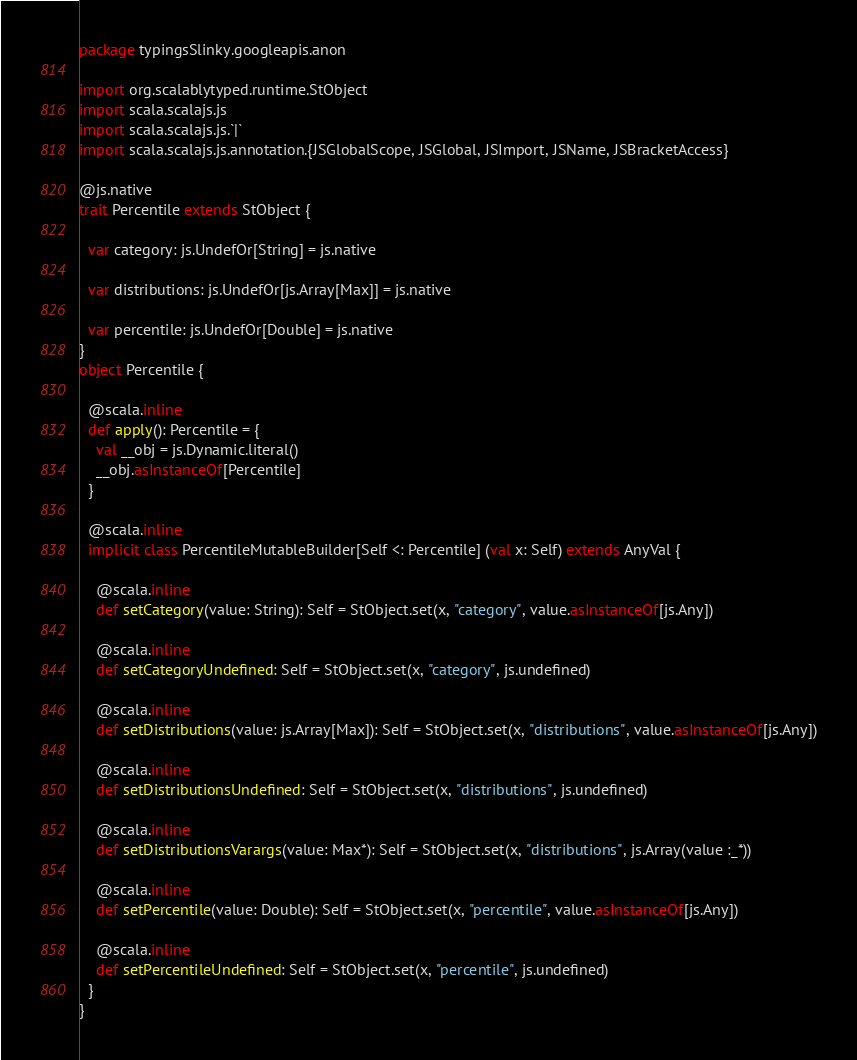Convert code to text. <code><loc_0><loc_0><loc_500><loc_500><_Scala_>package typingsSlinky.googleapis.anon

import org.scalablytyped.runtime.StObject
import scala.scalajs.js
import scala.scalajs.js.`|`
import scala.scalajs.js.annotation.{JSGlobalScope, JSGlobal, JSImport, JSName, JSBracketAccess}

@js.native
trait Percentile extends StObject {
  
  var category: js.UndefOr[String] = js.native
  
  var distributions: js.UndefOr[js.Array[Max]] = js.native
  
  var percentile: js.UndefOr[Double] = js.native
}
object Percentile {
  
  @scala.inline
  def apply(): Percentile = {
    val __obj = js.Dynamic.literal()
    __obj.asInstanceOf[Percentile]
  }
  
  @scala.inline
  implicit class PercentileMutableBuilder[Self <: Percentile] (val x: Self) extends AnyVal {
    
    @scala.inline
    def setCategory(value: String): Self = StObject.set(x, "category", value.asInstanceOf[js.Any])
    
    @scala.inline
    def setCategoryUndefined: Self = StObject.set(x, "category", js.undefined)
    
    @scala.inline
    def setDistributions(value: js.Array[Max]): Self = StObject.set(x, "distributions", value.asInstanceOf[js.Any])
    
    @scala.inline
    def setDistributionsUndefined: Self = StObject.set(x, "distributions", js.undefined)
    
    @scala.inline
    def setDistributionsVarargs(value: Max*): Self = StObject.set(x, "distributions", js.Array(value :_*))
    
    @scala.inline
    def setPercentile(value: Double): Self = StObject.set(x, "percentile", value.asInstanceOf[js.Any])
    
    @scala.inline
    def setPercentileUndefined: Self = StObject.set(x, "percentile", js.undefined)
  }
}
</code> 